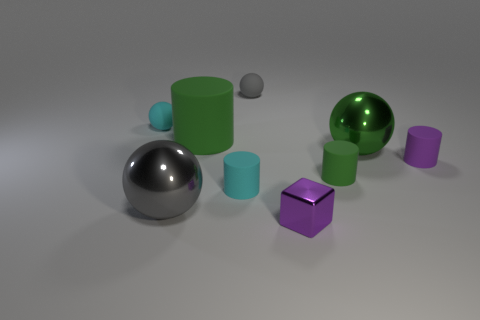Does the shiny cube have the same size as the green metal sphere?
Offer a terse response. No. What number of other things are the same size as the gray shiny object?
Give a very brief answer. 2. How many objects are either small rubber objects that are to the left of the small purple shiny object or big objects in front of the large green cylinder?
Your response must be concise. 5. What shape is the purple rubber object that is the same size as the cyan rubber ball?
Offer a very short reply. Cylinder. What is the size of the gray sphere that is the same material as the small green cylinder?
Ensure brevity in your answer.  Small. Is the big gray metal object the same shape as the tiny green object?
Your answer should be very brief. No. There is a metallic cube that is the same size as the gray matte thing; what color is it?
Provide a short and direct response. Purple. What size is the purple matte thing that is the same shape as the big green matte thing?
Give a very brief answer. Small. There is a big green thing that is right of the small gray thing; what shape is it?
Provide a short and direct response. Sphere. Is the shape of the small metal object the same as the large metallic thing that is on the right side of the gray matte thing?
Offer a very short reply. No. 